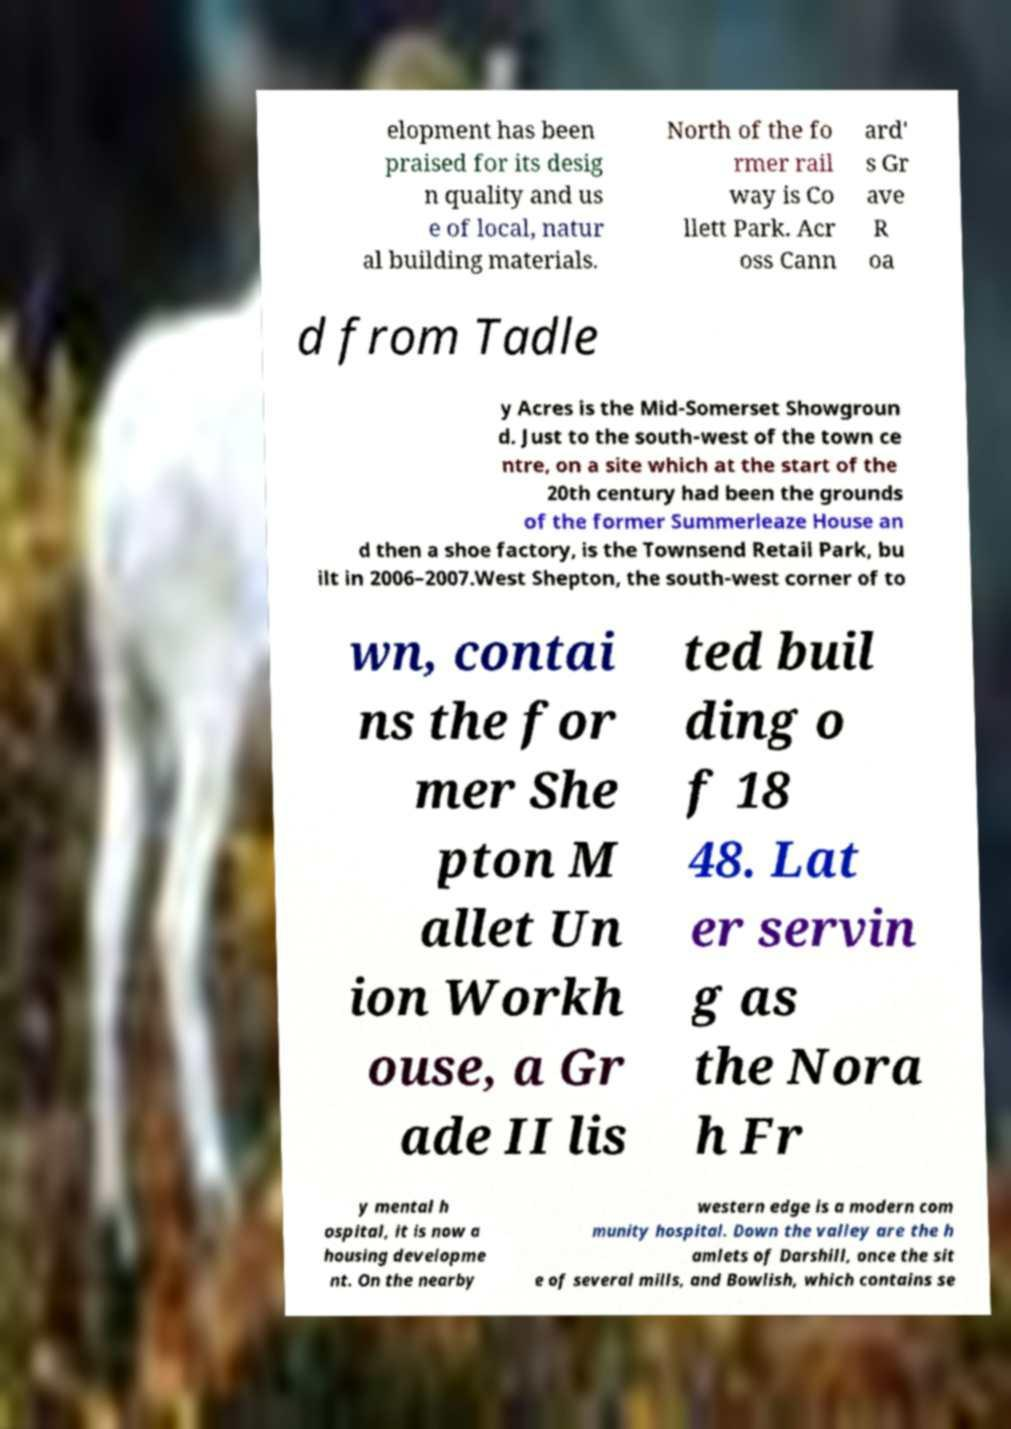For documentation purposes, I need the text within this image transcribed. Could you provide that? elopment has been praised for its desig n quality and us e of local, natur al building materials. North of the fo rmer rail way is Co llett Park. Acr oss Cann ard' s Gr ave R oa d from Tadle y Acres is the Mid-Somerset Showgroun d. Just to the south-west of the town ce ntre, on a site which at the start of the 20th century had been the grounds of the former Summerleaze House an d then a shoe factory, is the Townsend Retail Park, bu ilt in 2006–2007.West Shepton, the south-west corner of to wn, contai ns the for mer She pton M allet Un ion Workh ouse, a Gr ade II lis ted buil ding o f 18 48. Lat er servin g as the Nora h Fr y mental h ospital, it is now a housing developme nt. On the nearby western edge is a modern com munity hospital. Down the valley are the h amlets of Darshill, once the sit e of several mills, and Bowlish, which contains se 